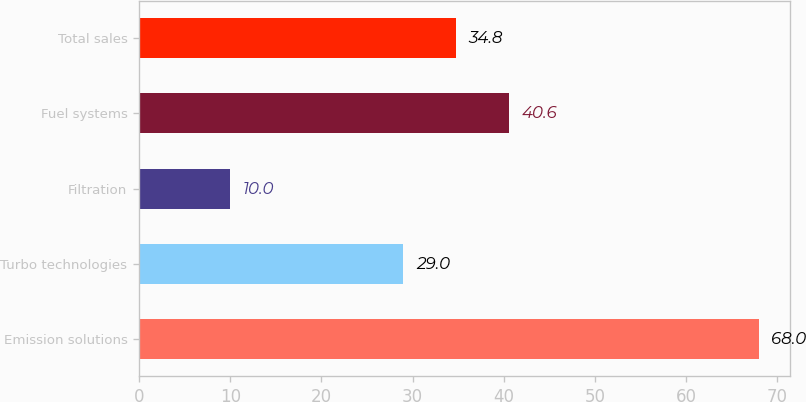Convert chart to OTSL. <chart><loc_0><loc_0><loc_500><loc_500><bar_chart><fcel>Emission solutions<fcel>Turbo technologies<fcel>Filtration<fcel>Fuel systems<fcel>Total sales<nl><fcel>68<fcel>29<fcel>10<fcel>40.6<fcel>34.8<nl></chart> 